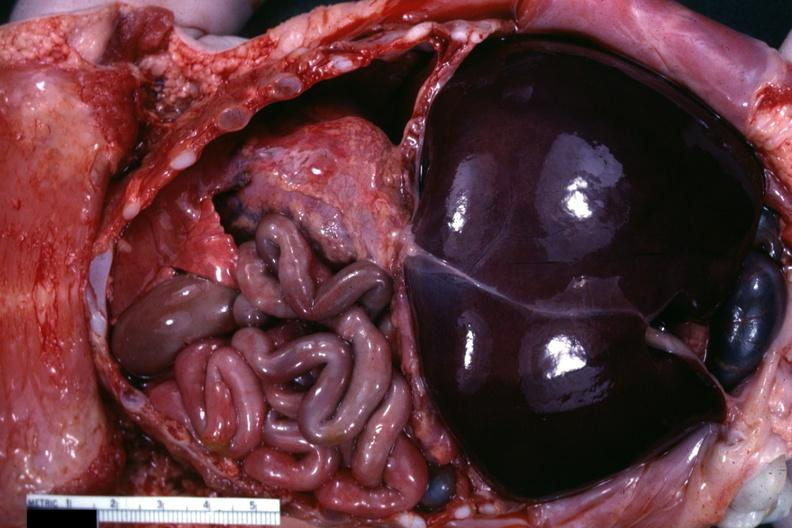s muscle present?
Answer the question using a single word or phrase. Yes 